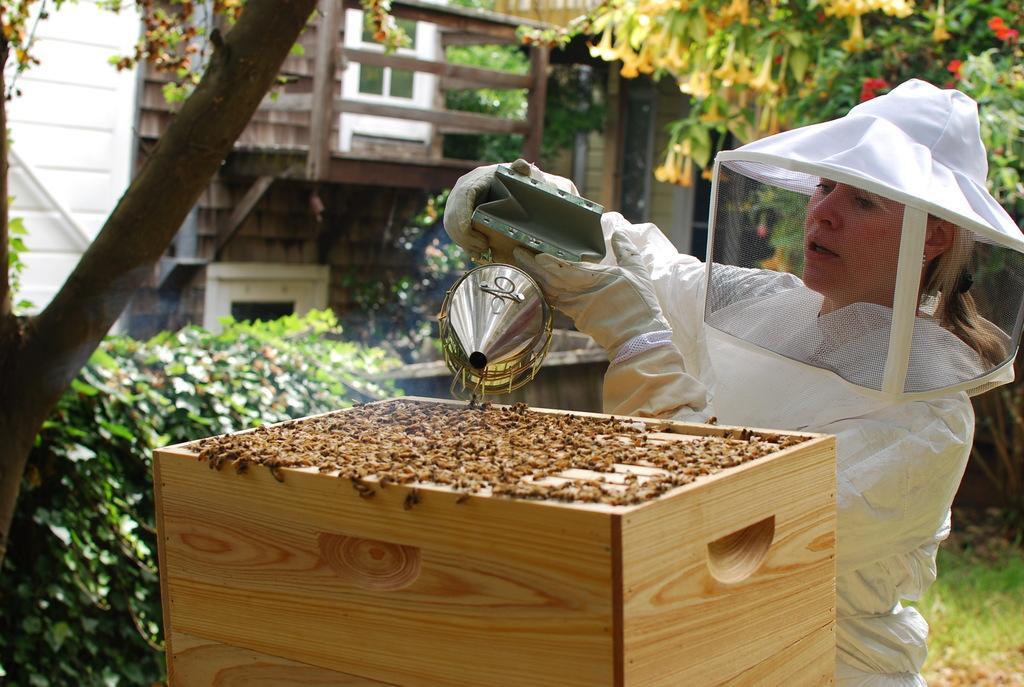Could you give a brief overview of what you see in this image? In this image, we can see a lady wearing a coat, gloves and a face protection cap and holding an object. In the background, there are trees, buildings, bushes and we can see bees on the stand. 